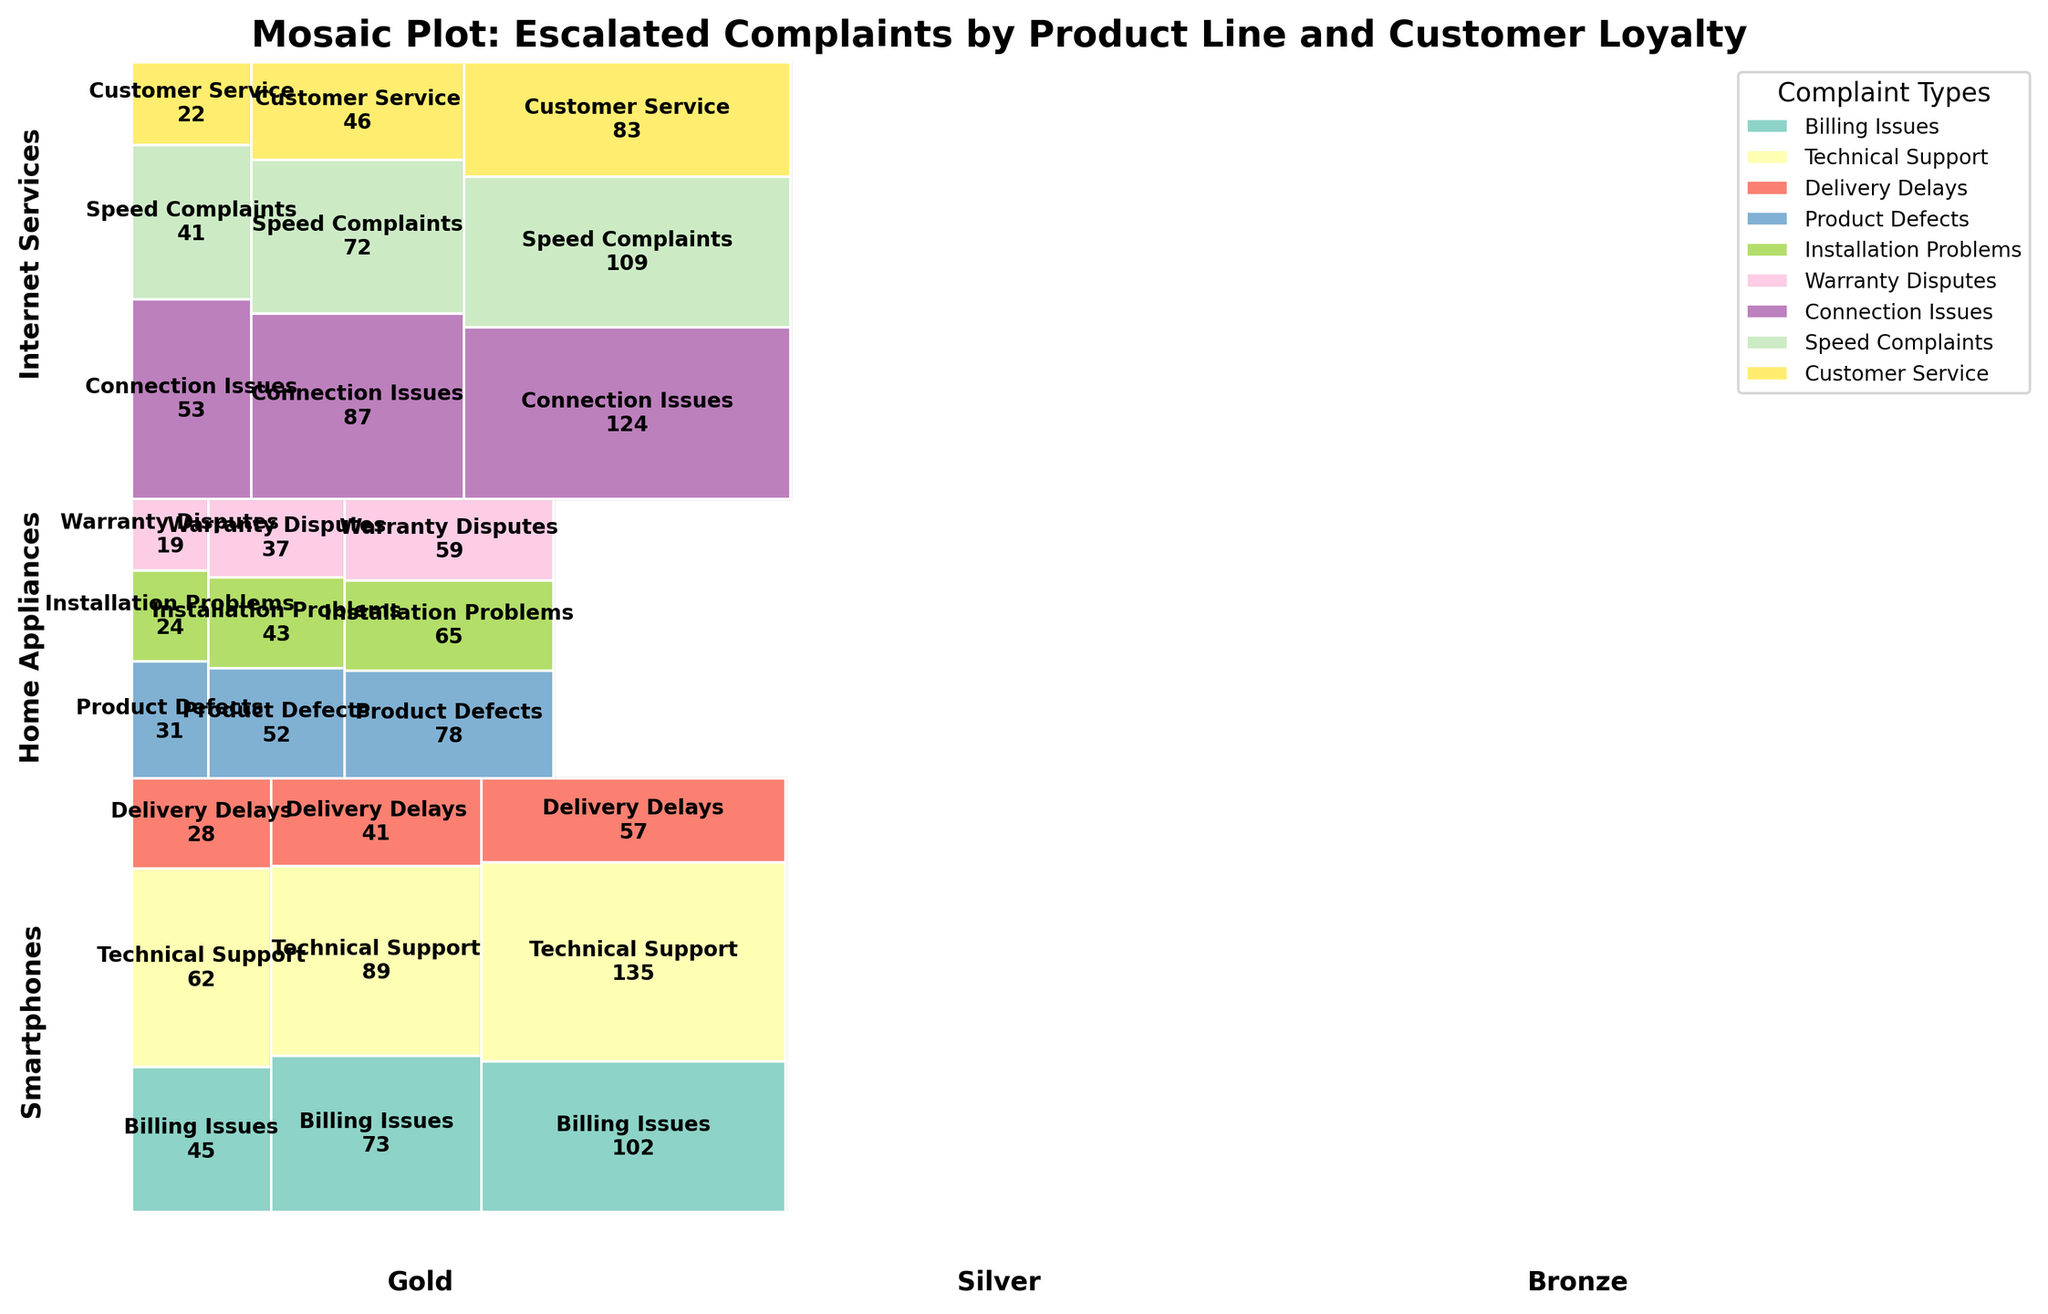Which product line has the highest number of complaints for bronze loyalty status? Check the height of each bar in the bronze loyalty status column. Internet Services has the highest bar.
Answer: Internet Services What type of complaint is most common among Gold loyalty customers for Smartphones? Look at the different colors within the section for Gold loyalty and Smartphones. The highest section is Technical Support.
Answer: Technical Support Compare the number of Billing Issues in Silver and Bronze loyalty status for Smartphones. Which is higher? Compare the heights of the 'Billing Issues' sections in the Silver and Bronze loyalty status columns within Smartphone. Bronze is higher.
Answer: Bronze What is the combined total number of complaints for Internet Services among Gold and Silver loyalty customers? Add the counts for Gold and Silver loyalty in the Internet Services category. Gold: 53+41+22 = 116, Silver: 87+72+46 = 205. Total = 116 + 205 = 321
Answer: 321 Which category has the fewest number of complaints overall? Compare the sizes of all categories across the mosaic plot. "Warranty Disputes" under Gold Home Appliances is the smallest.
Answer: Warranty Disputes Which loyalty status has the most complaints in total for Home Appliances? Sum the heights of all complaint categories within each loyalty status for Home Appliances. Bronze loyalty status is the tallest.
Answer: Bronze Is the number of Technical Support complaints in Silver loyalty status for Smartphones greater than the number of Installation Problems complaints in Bronze loyalty status for Home Appliances? Compare the heights of the 'Technical Support' section within Silver Smartphones and 'Installation Problems' within Bronze Home Appliances. Technical Support is higher.
Answer: Yes What is the ratio of connection issues complaints between Bronze and Gold loyalty statuses for Internet Services? Count the connection issues for Bronze (124) and Gold (53), then calculate the ratio 124/53, which simplifies to approximately 2.34.
Answer: 2.34 How many more Billing Issues complaints are there in Bronze loyalty status for Smartphones than in Gold loyalty status for the same product? Count the 'Billing Issues' complaints for Bronze (102) and Gold (45), then subtract 102 - 45 = 57.
Answer: 57 